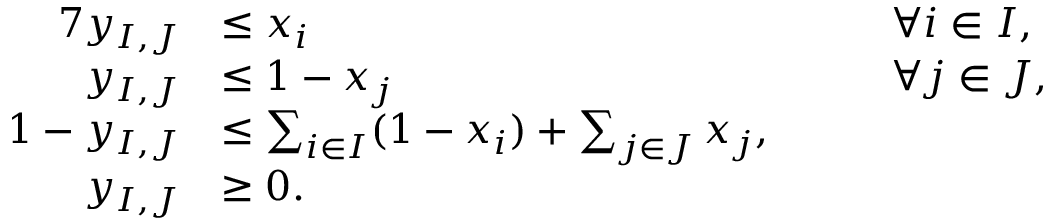<formula> <loc_0><loc_0><loc_500><loc_500>\begin{array} { r l r l } { { 7 } y _ { I , J } } & { \leq x _ { i } } & { \quad } & { \forall i \in I , } \\ { y _ { I , J } } & { \leq 1 - x _ { j } } & { \quad } & { \forall j \in J , } \\ { 1 - y _ { I , J } } & { \leq \sum _ { i \in I } ( 1 - x _ { i } ) + \sum _ { j \in J } x _ { j } , } \\ { y _ { I , J } } & { \geq 0 . } \end{array}</formula> 